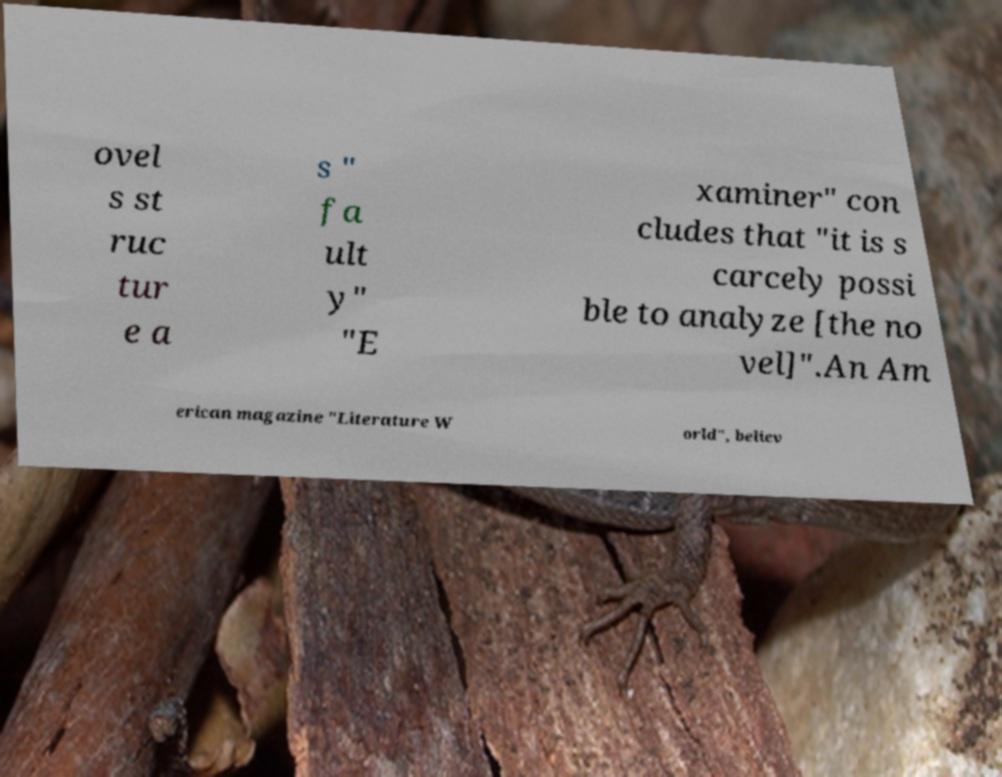Please identify and transcribe the text found in this image. ovel s st ruc tur e a s " fa ult y" "E xaminer" con cludes that "it is s carcely possi ble to analyze [the no vel]".An Am erican magazine "Literature W orld", believ 